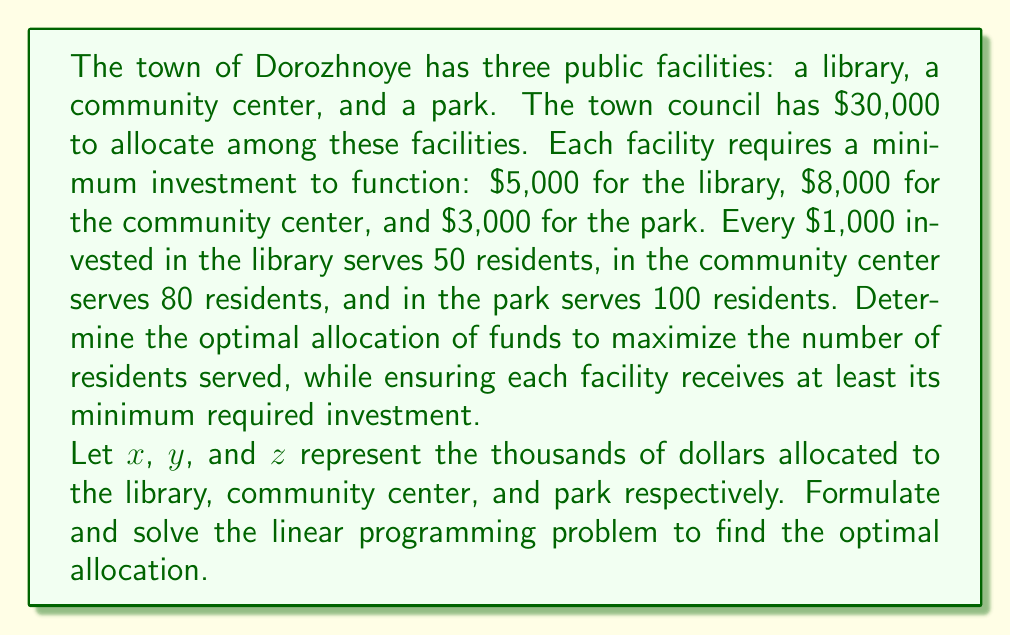Help me with this question. To solve this problem, we need to set up a linear programming model and then solve it. Let's break it down step by step:

1) Define the objective function:
   We want to maximize the number of residents served.
   Objective function: Maximize $50x + 80y + 100z$

2) Define the constraints:
   a) Budget constraint: $x + y + z \leq 30$ (total budget is $30,000)
   b) Minimum investments: 
      $x \geq 5$ (library needs at least $5,000)
      $y \geq 8$ (community center needs at least $8,000)
      $z \geq 3$ (park needs at least $3,000)

3) Non-negativity constraints:
   $x, y, z \geq 0$

4) The complete linear programming model:

   Maximize $50x + 80y + 100z$
   Subject to:
   $x + y + z \leq 30$
   $x \geq 5$
   $y \geq 8$
   $z \geq 3$
   $x, y, z \geq 0$

5) To solve this, we can use the simplex method or a graphical method. In this case, we'll use reasoning to find the optimal solution:

   - The park gives the highest return (100 residents per $1,000), so we should allocate as much as possible to the park after meeting minimum requirements.
   - After allocating the minimums ($5,000 to library, $8,000 to community center, $3,000 to park), we have $14,000 left.
   - We should allocate all of this remaining money to the park.

6) Therefore, the optimal solution is:
   $x = 5$ (library gets $5,000)
   $y = 8$ (community center gets $8,000)
   $z = 17$ (park gets $3,000 minimum + $14,000 extra = $17,000)

7) We can verify that this satisfies all constraints:
   $5 + 8 + 17 = 30$ (budget constraint satisfied)
   $x, y, z$ are all at least their minimum required values
   
8) Calculate the number of residents served:
   $50(5) + 80(8) + 100(17) = 250 + 640 + 1700 = 2590$
Answer: The optimal allocation is $5,000 to the library, $8,000 to the community center, and $17,000 to the park. This allocation will serve a maximum of 2,590 residents. 